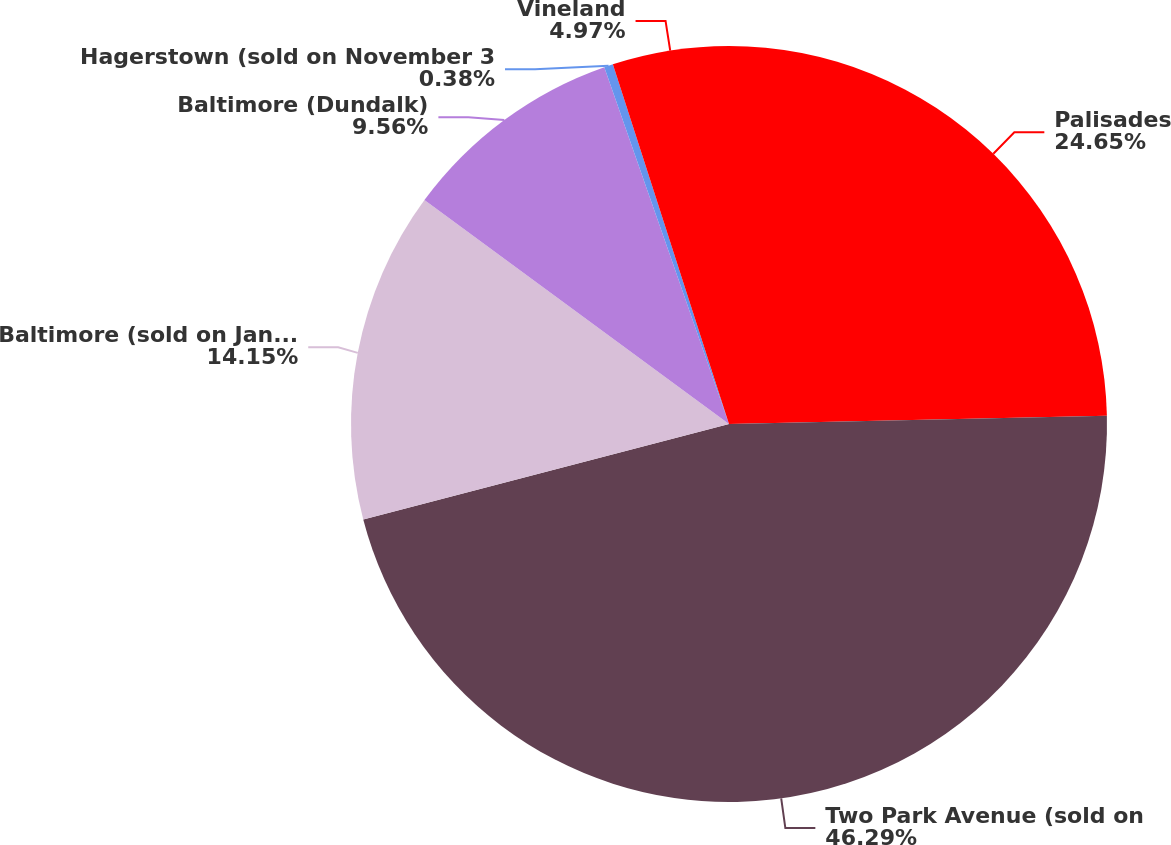<chart> <loc_0><loc_0><loc_500><loc_500><pie_chart><fcel>Palisades<fcel>Two Park Avenue (sold on<fcel>Baltimore (sold on January 9<fcel>Baltimore (Dundalk)<fcel>Hagerstown (sold on November 3<fcel>Vineland<nl><fcel>24.65%<fcel>46.28%<fcel>14.15%<fcel>9.56%<fcel>0.38%<fcel>4.97%<nl></chart> 